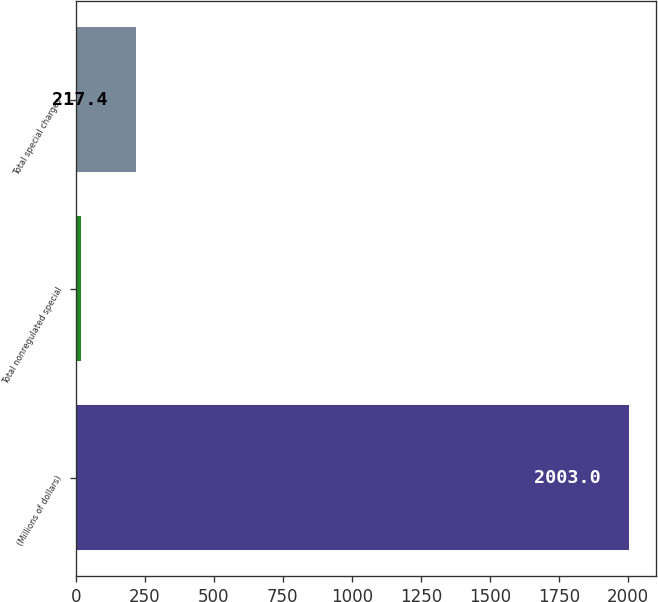Convert chart to OTSL. <chart><loc_0><loc_0><loc_500><loc_500><bar_chart><fcel>(Millions of dollars)<fcel>Total nonregulated special<fcel>Total special charges<nl><fcel>2003<fcel>19<fcel>217.4<nl></chart> 